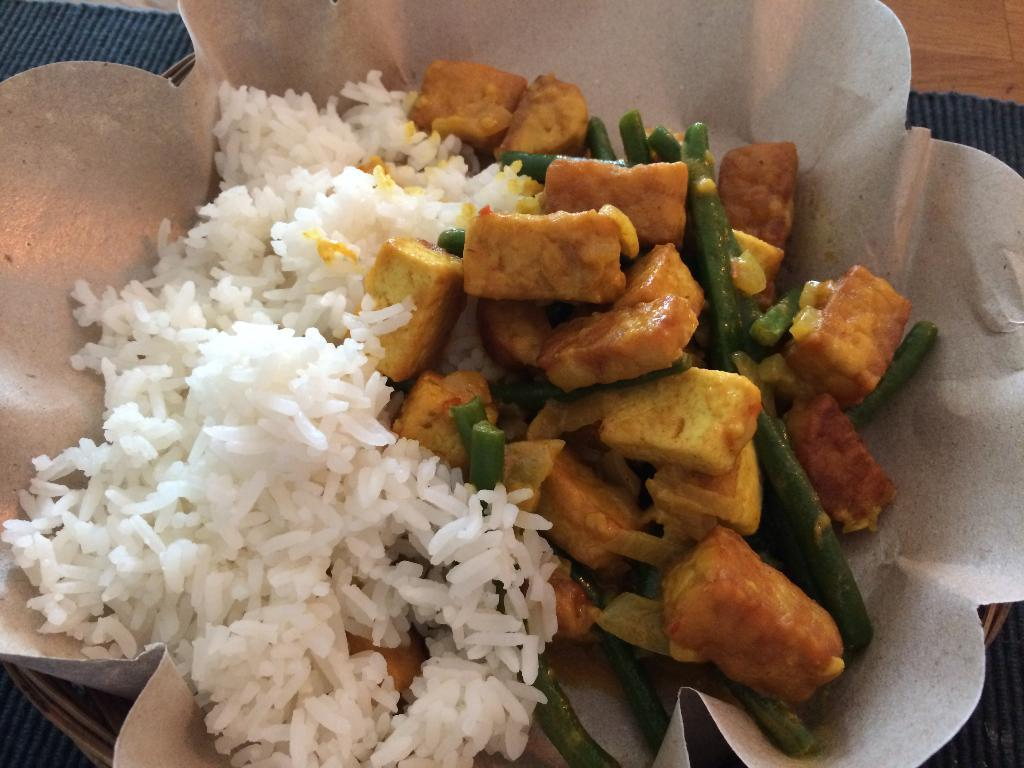What is located in the center of the image? There is a table in the center of the image. What is placed on the table? There is a mat and a basket on the table. What is inside the basket? There is a paper and food items in the basket. What type of lumber is being used to construct the table in the image? There is no information about the construction material of the table in the image. 